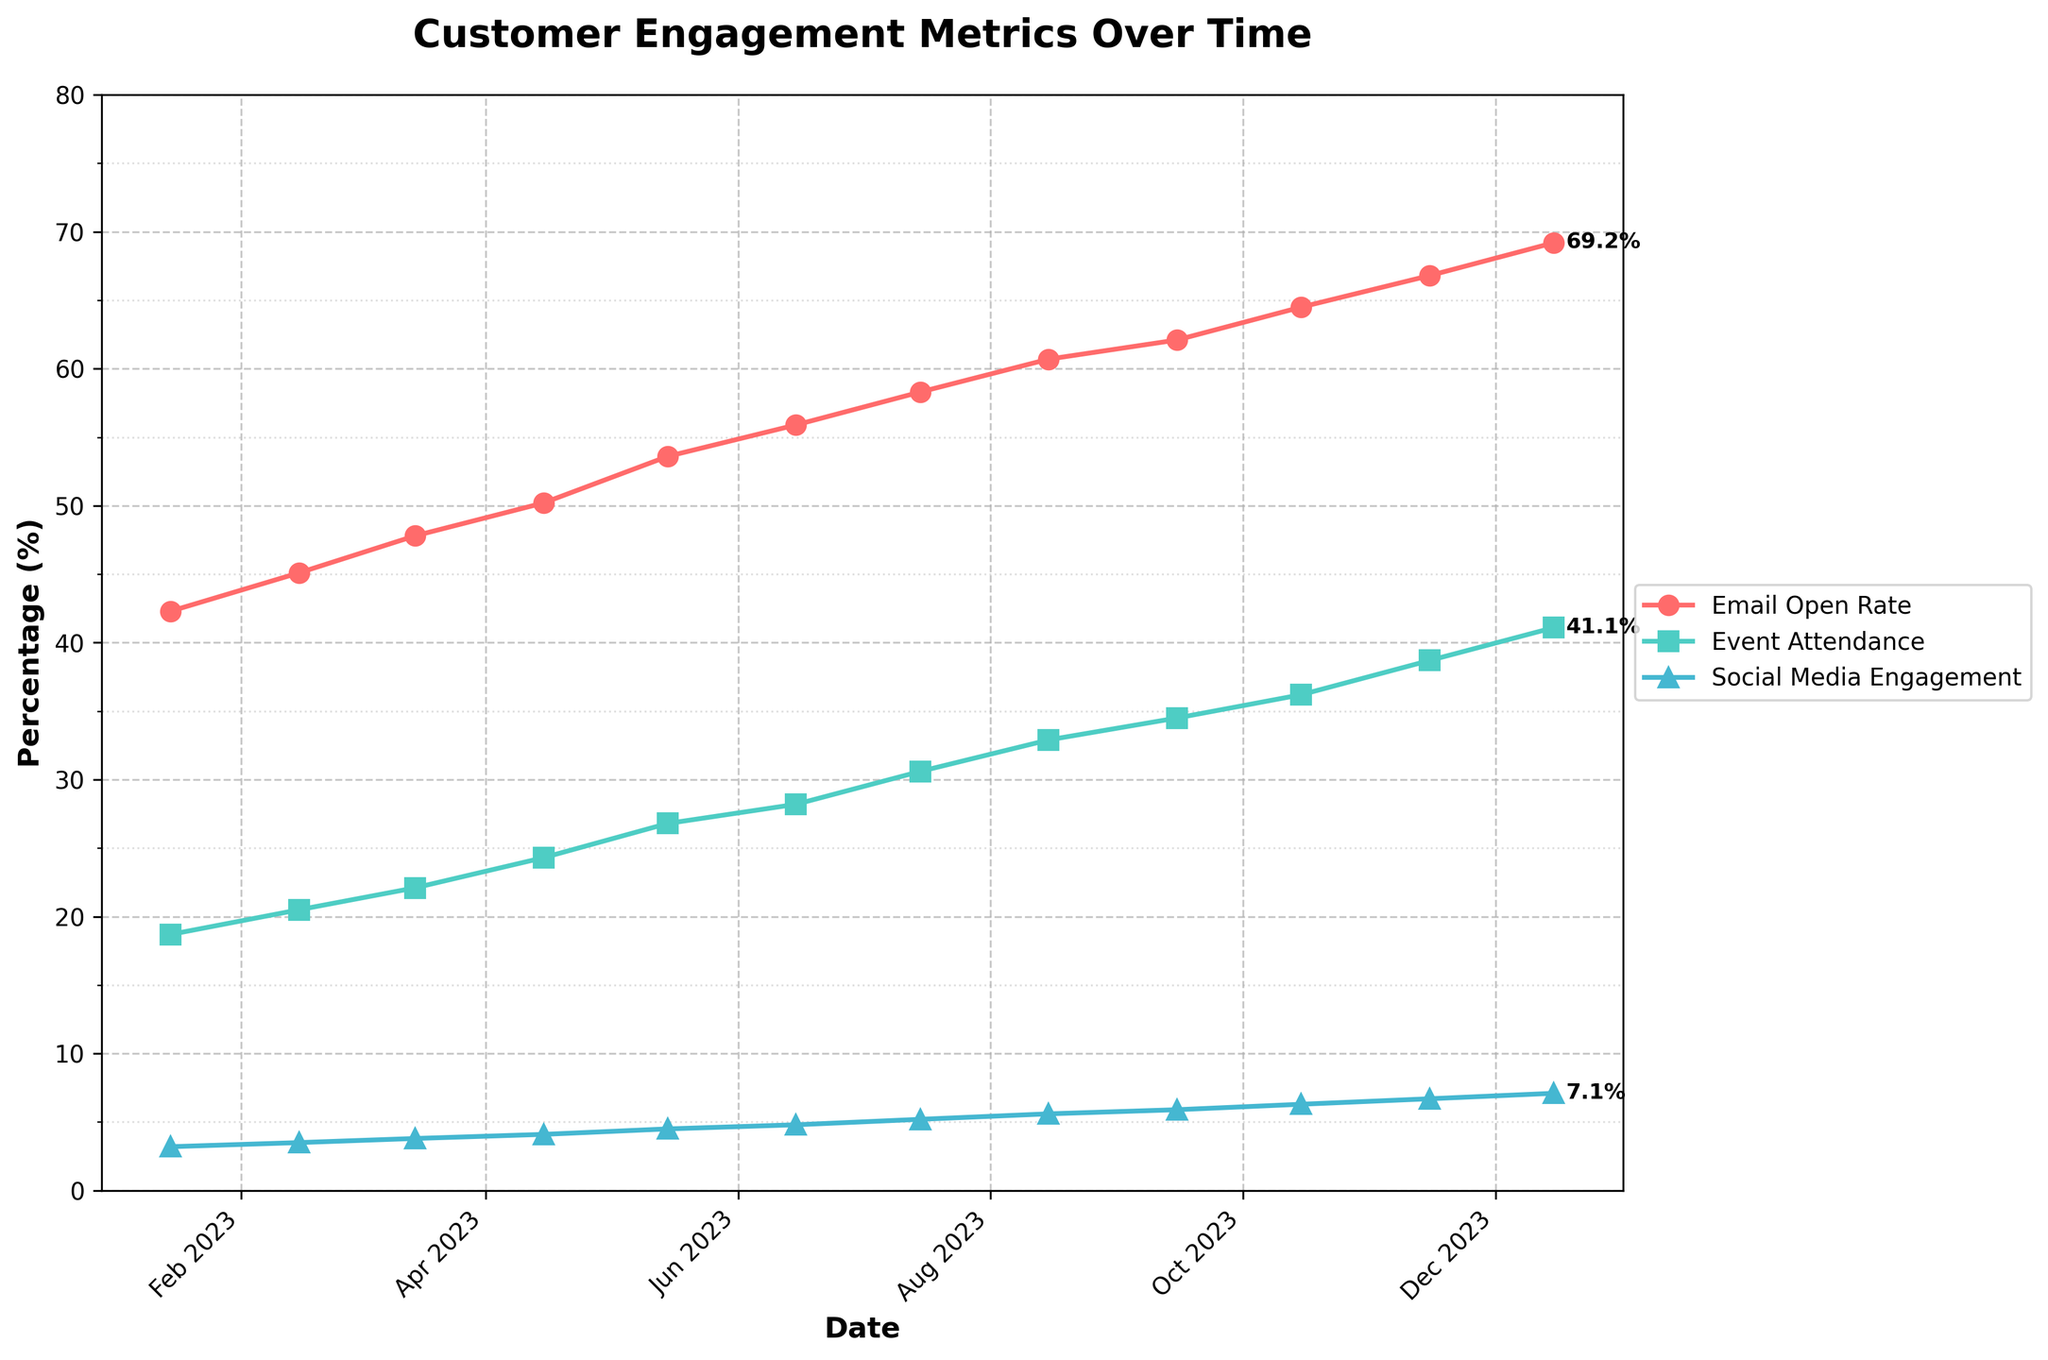Which metric shows the highest increase over the year? By observing the three lines in the figure, we compare the start and end points in January and December. The biggest jump from January to December is in the "Email Open Rate" from 42.3% to 69.2%.
Answer: Email Open Rate Which type of engagement had the lowest percentage in October 2023? By looking at the graph for October 2023, the line with the lowest point among the three metrics is the "Social Media Engagement Rate" at 6.3%.
Answer: Social Media Engagement Rate How much did the event attendance change between July 2023 and December 2023? The "Event Attendance" rate in July 2023 is 30.6%, and in December 2023 it is 41.1%. The change is computed by subtracting 30.6 from 41.1: 41.1 - 30.6 = 10.5%
Answer: 10.5% Is the social media engagement rate higher in January 2023 or July 2023? By observing the points on the graph for January and July, the "Social Media Engagement Rate" is 3.2% in January and 5.2% in July. 5.2% is higher than 3.2%.
Answer: July 2023 On which date do all three metrics show notable increases compared to the previous date? By observing the graph, from August 2023 to September 2023, all three lines show a notable upward jump, indicating significant improvements across all metrics.
Answer: September 2023 What is the gap between the email open rate and event attendance rate in November 2023? The "Email Open Rate" in November 2023 is 66.8%, and the "Event Attendance" rate is 38.7%. The gap is calculated by subtracting 38.7 from 66.8: 66.8 - 38.7 = 28.1%
Answer: 28.1% Which metric has the smallest increase from month to month? By visually comparing the slopes of the three lines, the "Social Media Engagement Rate" has the smallest and most gradual increase each month.
Answer: Social Media Engagement Rate What is the visual characteristic of the "Event Attendance" line in the graph? The "Event Attendance" line is represented with square markers and a green line. It shows a steady upward trend from January to December.
Answer: Green line with square markers What is the difference in the social media engagement rate between the highest and the lowest recorded value? The highest recorded value for "Social Media Engagement Rate" is in December 2023 at 7.1%, and the lowest is in January 2023 at 3.2%. The difference is 7.1 - 3.2 = 3.9%.
Answer: 3.9% 